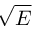Convert formula to latex. <formula><loc_0><loc_0><loc_500><loc_500>\sqrt { E }</formula> 